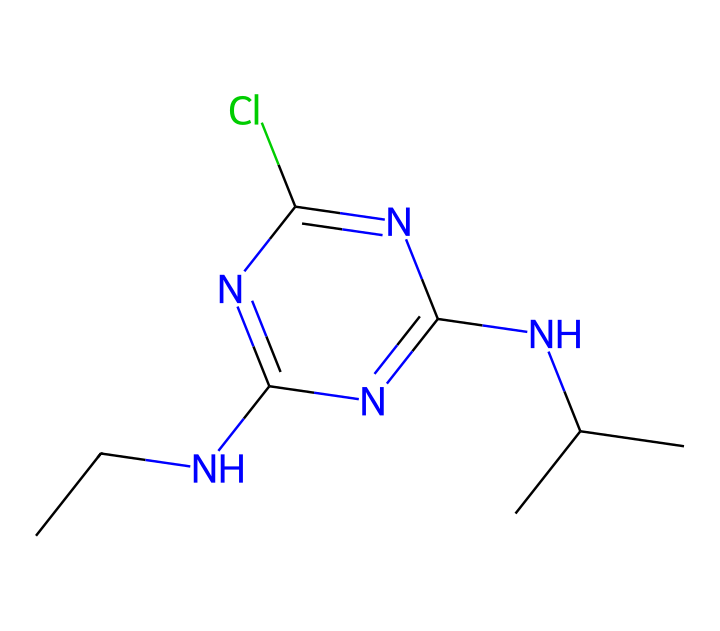What is the molecular formula of atrazine? The molecular structure has several components, including carbon (C), hydrogen (H), chlorine (Cl), and nitrogen (N). By counting the individual atoms represented in the SMILES string, we can deduce that the molecular formula is C8H14ClN5.
Answer: C8H14ClN5 How many nitrogen atoms are present in atrazine? By examining the SMILES representation, we can identify the nitrogen (N) atoms. There are five nitrogen atoms represented in this structure.
Answer: 5 Does atrazine contain any chlorine atoms? The SMILES structure includes a 'Cl' which indicates the presence of a chlorine atom.
Answer: Yes What functional groups are present in atrazine? The chemical structure features an amine group (due to the NH and N(CH3)2) and a chlorinated aromatic ring, which are key functional groups contributing to its properties as a herbicide.
Answer: Amine and aromatic What is the total number of carbon atoms in atrazine? In the SMILES notation, each "C" represents a carbon atom. Counting these, we find there are eight carbon atoms in the structure of atrazine.
Answer: 8 What is the role of atrazine in agriculture? Atrazine is a herbicide used to prevent the growth of weeds, particularly in crops like corn and sugarcane. It effectively inhibits photosynthesis in certain plants.
Answer: Herbicide 